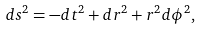<formula> <loc_0><loc_0><loc_500><loc_500>d s ^ { 2 } = - d t ^ { 2 } + d r ^ { 2 } + r ^ { 2 } d \phi ^ { 2 } ,</formula> 